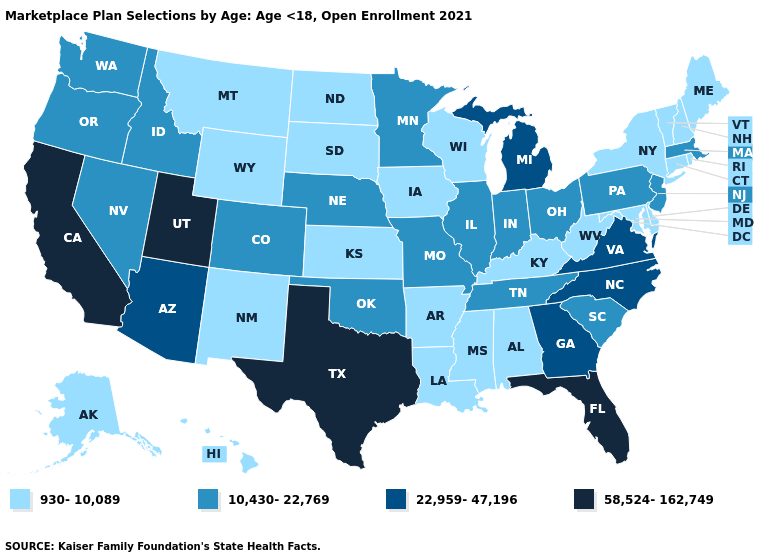Name the states that have a value in the range 22,959-47,196?
Be succinct. Arizona, Georgia, Michigan, North Carolina, Virginia. What is the value of Vermont?
Quick response, please. 930-10,089. Among the states that border Alabama , does Mississippi have the lowest value?
Answer briefly. Yes. Which states have the lowest value in the USA?
Answer briefly. Alabama, Alaska, Arkansas, Connecticut, Delaware, Hawaii, Iowa, Kansas, Kentucky, Louisiana, Maine, Maryland, Mississippi, Montana, New Hampshire, New Mexico, New York, North Dakota, Rhode Island, South Dakota, Vermont, West Virginia, Wisconsin, Wyoming. What is the lowest value in the USA?
Be succinct. 930-10,089. What is the value of Pennsylvania?
Keep it brief. 10,430-22,769. What is the value of Vermont?
Quick response, please. 930-10,089. What is the highest value in states that border Wisconsin?
Quick response, please. 22,959-47,196. Which states have the lowest value in the USA?
Concise answer only. Alabama, Alaska, Arkansas, Connecticut, Delaware, Hawaii, Iowa, Kansas, Kentucky, Louisiana, Maine, Maryland, Mississippi, Montana, New Hampshire, New Mexico, New York, North Dakota, Rhode Island, South Dakota, Vermont, West Virginia, Wisconsin, Wyoming. Does the first symbol in the legend represent the smallest category?
Write a very short answer. Yes. Which states have the lowest value in the West?
Be succinct. Alaska, Hawaii, Montana, New Mexico, Wyoming. Name the states that have a value in the range 930-10,089?
Give a very brief answer. Alabama, Alaska, Arkansas, Connecticut, Delaware, Hawaii, Iowa, Kansas, Kentucky, Louisiana, Maine, Maryland, Mississippi, Montana, New Hampshire, New Mexico, New York, North Dakota, Rhode Island, South Dakota, Vermont, West Virginia, Wisconsin, Wyoming. Name the states that have a value in the range 58,524-162,749?
Concise answer only. California, Florida, Texas, Utah. Which states have the lowest value in the West?
Give a very brief answer. Alaska, Hawaii, Montana, New Mexico, Wyoming. What is the value of Kansas?
Quick response, please. 930-10,089. 